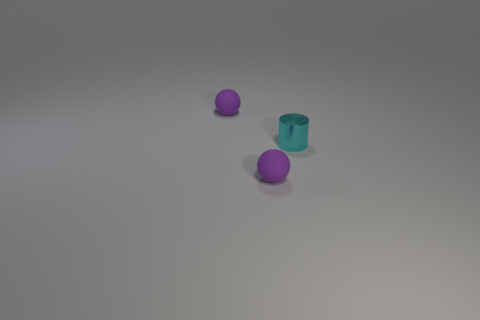Add 3 big brown cylinders. How many objects exist? 6 Subtract 1 balls. How many balls are left? 1 Subtract all balls. Subtract all small cyan shiny objects. How many objects are left? 0 Add 2 cyan metallic objects. How many cyan metallic objects are left? 3 Add 3 cyan things. How many cyan things exist? 4 Subtract 0 brown spheres. How many objects are left? 3 Subtract all spheres. How many objects are left? 1 Subtract all green spheres. Subtract all gray cylinders. How many spheres are left? 2 Subtract all gray cylinders. How many blue balls are left? 0 